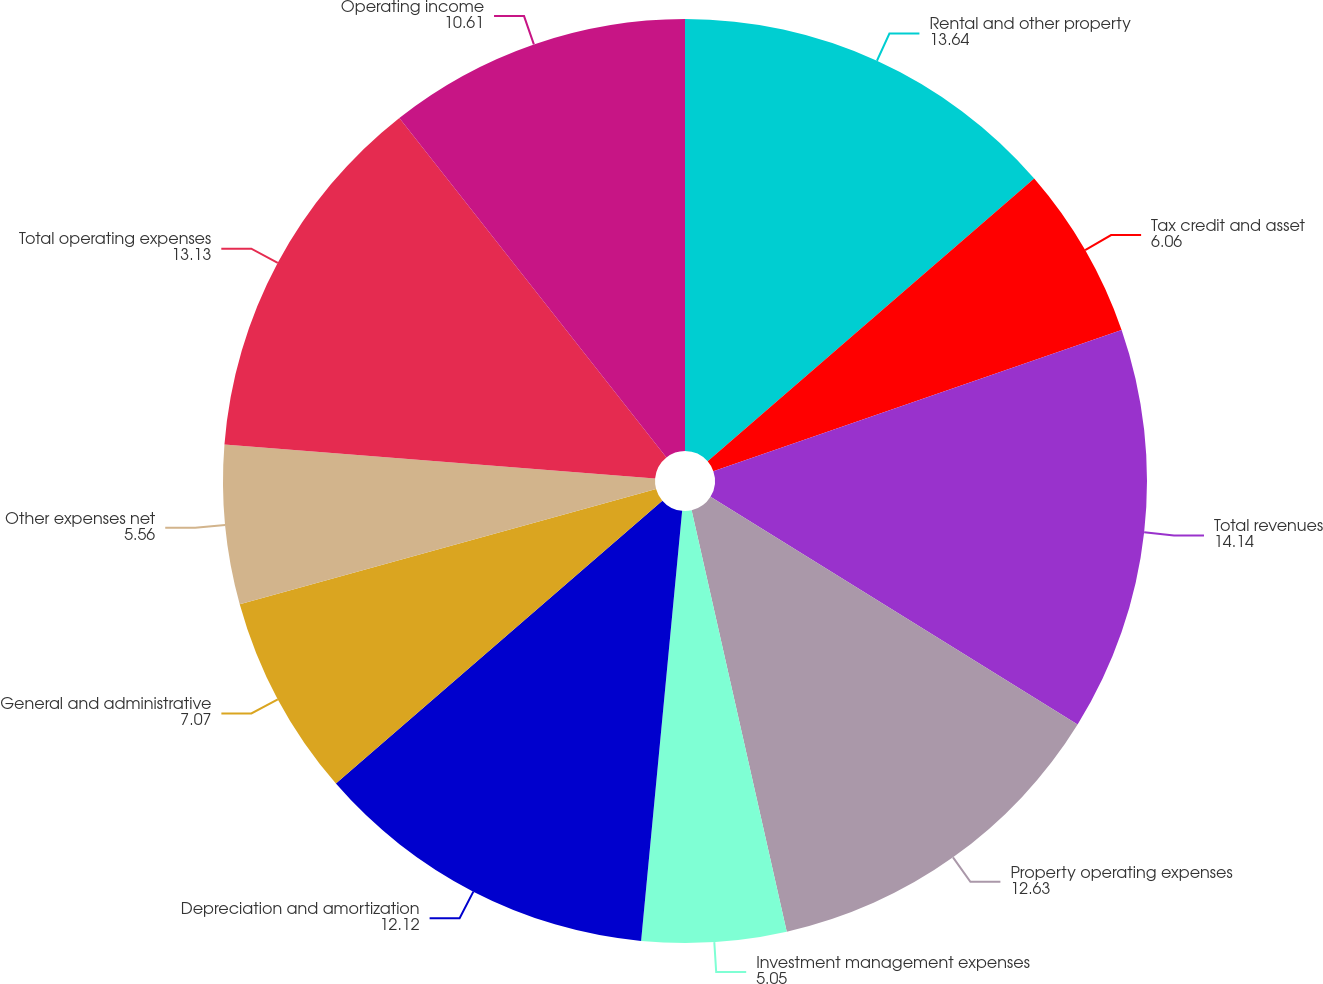Convert chart to OTSL. <chart><loc_0><loc_0><loc_500><loc_500><pie_chart><fcel>Rental and other property<fcel>Tax credit and asset<fcel>Total revenues<fcel>Property operating expenses<fcel>Investment management expenses<fcel>Depreciation and amortization<fcel>General and administrative<fcel>Other expenses net<fcel>Total operating expenses<fcel>Operating income<nl><fcel>13.64%<fcel>6.06%<fcel>14.14%<fcel>12.63%<fcel>5.05%<fcel>12.12%<fcel>7.07%<fcel>5.56%<fcel>13.13%<fcel>10.61%<nl></chart> 